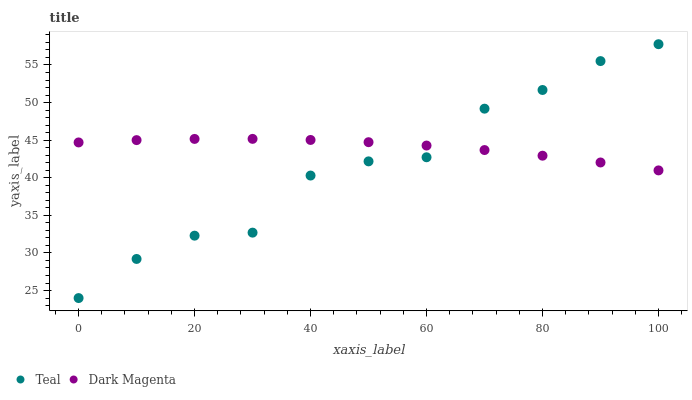Does Teal have the minimum area under the curve?
Answer yes or no. Yes. Does Dark Magenta have the maximum area under the curve?
Answer yes or no. Yes. Does Teal have the maximum area under the curve?
Answer yes or no. No. Is Dark Magenta the smoothest?
Answer yes or no. Yes. Is Teal the roughest?
Answer yes or no. Yes. Is Teal the smoothest?
Answer yes or no. No. Does Teal have the lowest value?
Answer yes or no. Yes. Does Teal have the highest value?
Answer yes or no. Yes. Does Dark Magenta intersect Teal?
Answer yes or no. Yes. Is Dark Magenta less than Teal?
Answer yes or no. No. Is Dark Magenta greater than Teal?
Answer yes or no. No. 